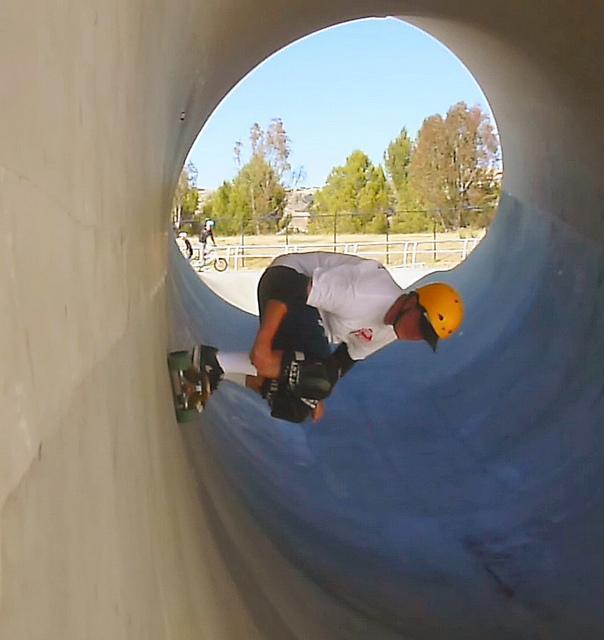How many stacks of bowls are there?
Give a very brief answer. 0. 